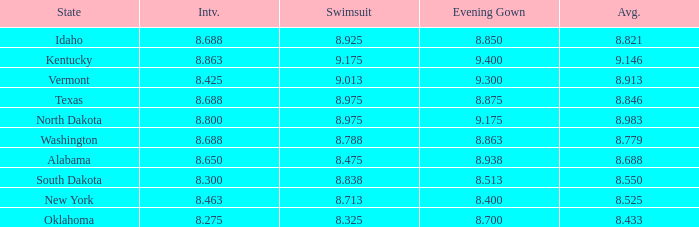What is the lowest evening score of the contestant with an evening gown less than 8.938, from Texas, and with an average less than 8.846 has? None. 